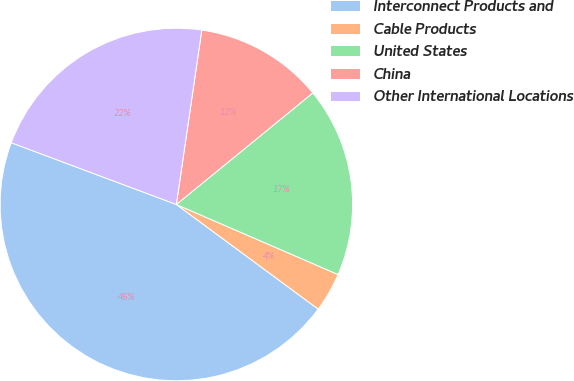Convert chart to OTSL. <chart><loc_0><loc_0><loc_500><loc_500><pie_chart><fcel>Interconnect Products and<fcel>Cable Products<fcel>United States<fcel>China<fcel>Other International Locations<nl><fcel>45.58%<fcel>3.61%<fcel>17.41%<fcel>11.79%<fcel>21.61%<nl></chart> 